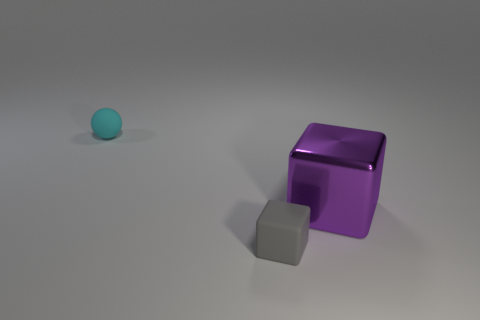Add 2 big purple metal things. How many objects exist? 5 Subtract all balls. How many objects are left? 2 Add 2 cyan rubber balls. How many cyan rubber balls exist? 3 Subtract 0 green blocks. How many objects are left? 3 Subtract all small blocks. Subtract all cyan objects. How many objects are left? 1 Add 1 small gray matte cubes. How many small gray matte cubes are left? 2 